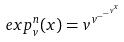Convert formula to latex. <formula><loc_0><loc_0><loc_500><loc_500>e x p _ { v } ^ { n } ( x ) = v ^ { v ^ { - ^ { - ^ { v ^ { x } } } } }</formula> 